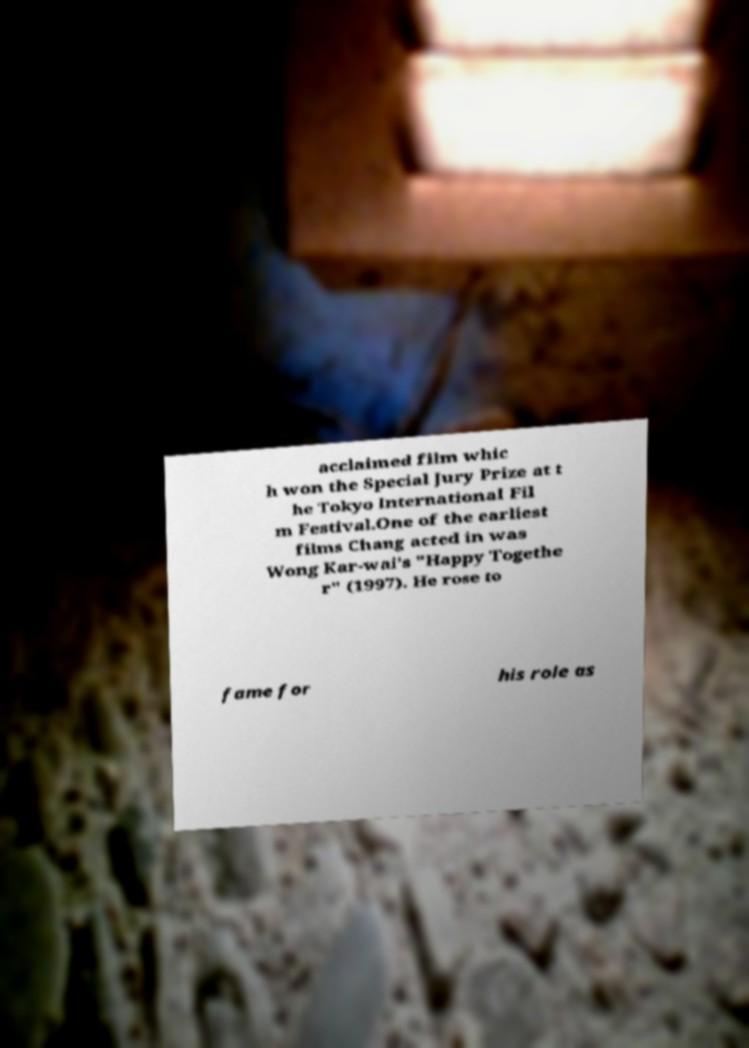Can you accurately transcribe the text from the provided image for me? acclaimed film whic h won the Special Jury Prize at t he Tokyo International Fil m Festival.One of the earliest films Chang acted in was Wong Kar-wai's "Happy Togethe r" (1997). He rose to fame for his role as 